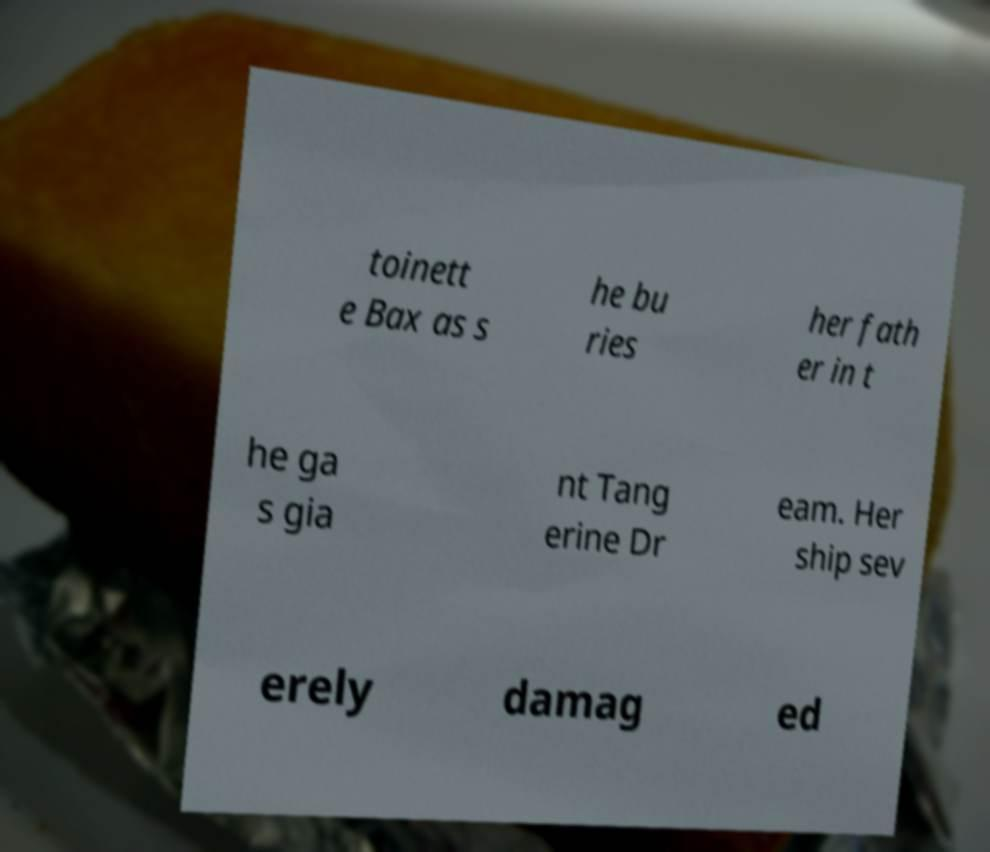Could you assist in decoding the text presented in this image and type it out clearly? toinett e Bax as s he bu ries her fath er in t he ga s gia nt Tang erine Dr eam. Her ship sev erely damag ed 